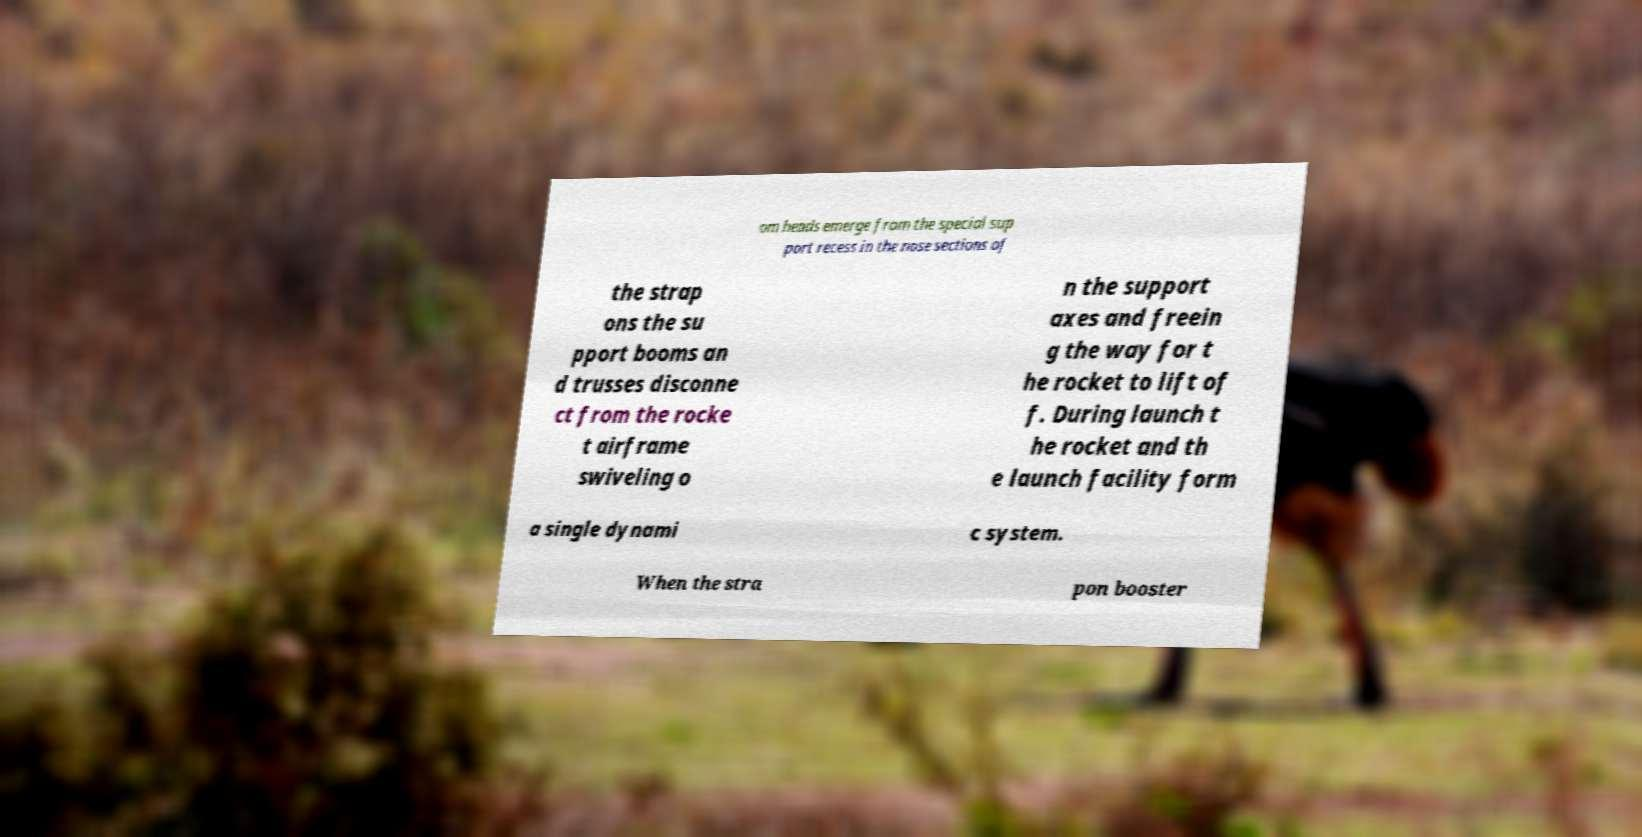Can you accurately transcribe the text from the provided image for me? om heads emerge from the special sup port recess in the nose sections of the strap ons the su pport booms an d trusses disconne ct from the rocke t airframe swiveling o n the support axes and freein g the way for t he rocket to lift of f. During launch t he rocket and th e launch facility form a single dynami c system. When the stra pon booster 